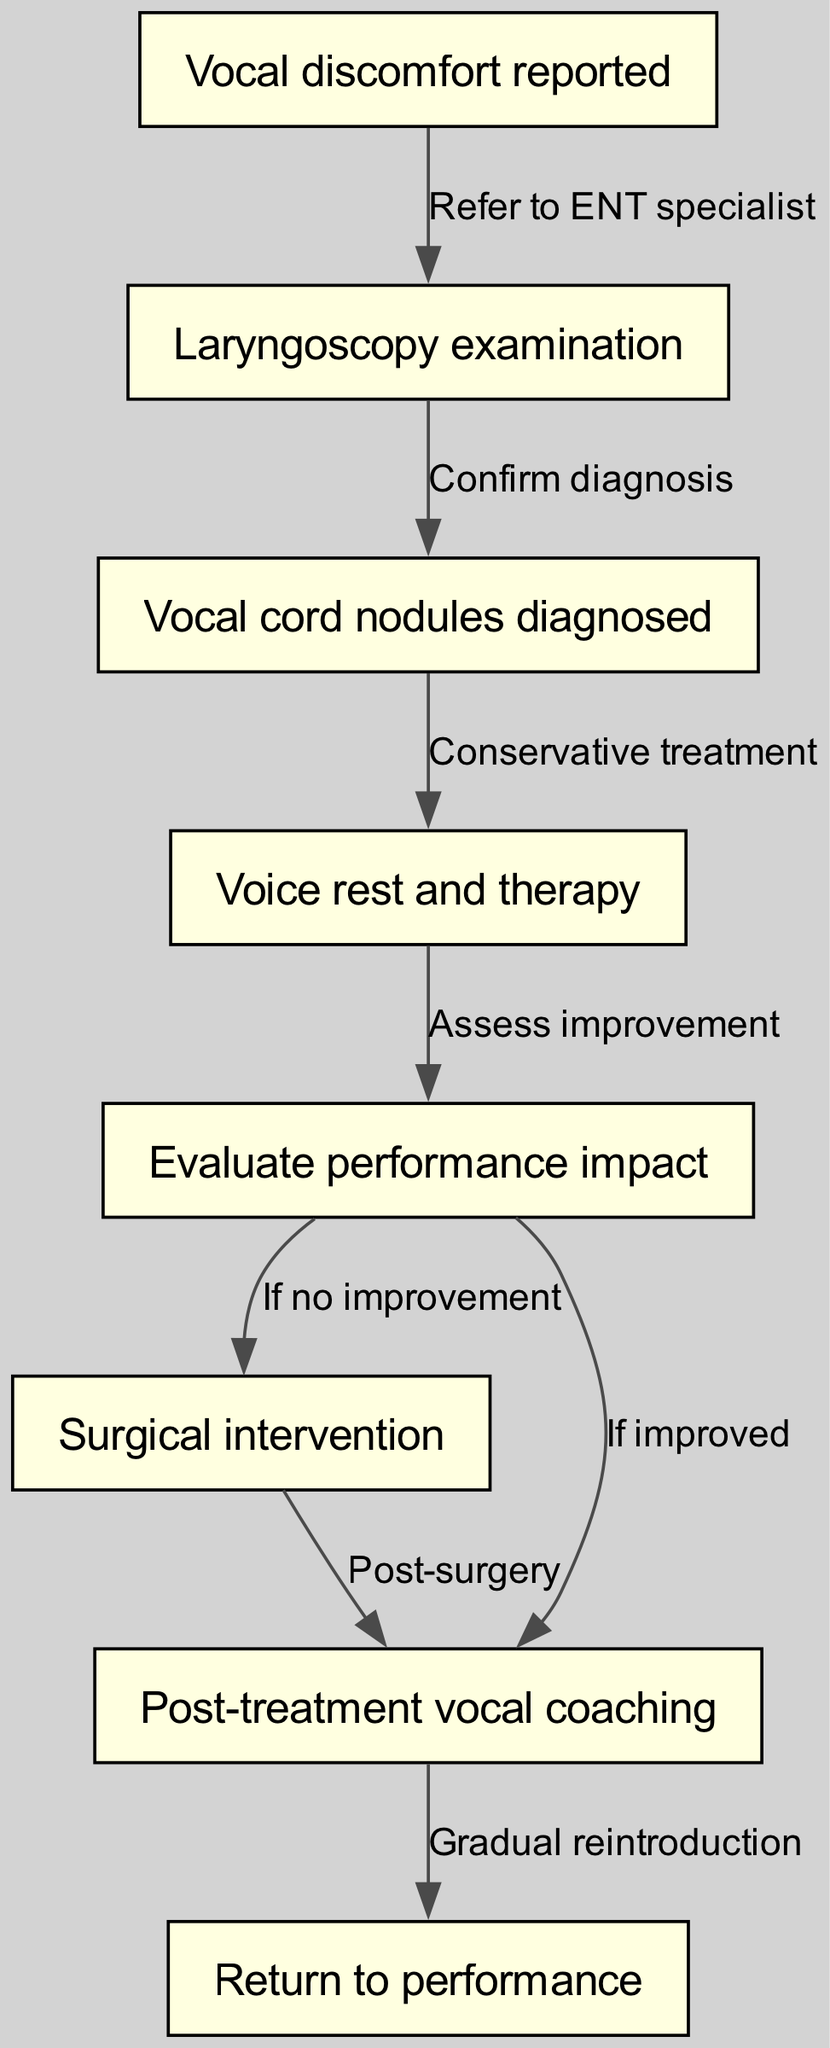What is the first node in the pathway? The first node in the pathway is labeled "Vocal discomfort reported," as indicated in the diagram's flow. It is where the process begins.
Answer: Vocal discomfort reported How many total nodes are in the diagram? By counting the unique nodes listed in the diagram, there are a total of eight nodes that represent different steps in the clinical pathway.
Answer: 8 What action is taken after a laryngoscopy examination? After a laryngoscopy examination, the action taken is to confirm the diagnosis, which leads to the identification of vocal cord nodules if present.
Answer: Confirm diagnosis What happens if there is no improvement after therapy? If there is no improvement after therapy, the next action in the pathway is to consider surgical intervention, which indicates a progression in treatment options.
Answer: Surgical intervention Which node comes after assessing improvement? Following the assessment of improvement, if the patient's condition has improved, the subsequent step outlined in the pathway is post-treatment vocal coaching.
Answer: Post-treatment vocal coaching What is the last step before returning to performance? The last step before returning to performance involves a gradual reintroduction, which is necessary to ensure the singer's recovery and readiness to perform again.
Answer: Gradual reintroduction What is the connection between vocal cord nodules diagnosed and voice rest and therapy? The connection is that vocal cord nodules diagnosed leads directly to the action of implementing voice rest and therapy, which represents a conservative treatment approach.
Answer: Conservative treatment What is the significance of the dashed line between the nodes? The dashed line indicates a conditional relationship, allowing for branching choices based on the outcome of assessing improvement. There are two possible paths: addressing either 'no improvement' with surgery or 'improved' with coaching.
Answer: Conditional relationship 